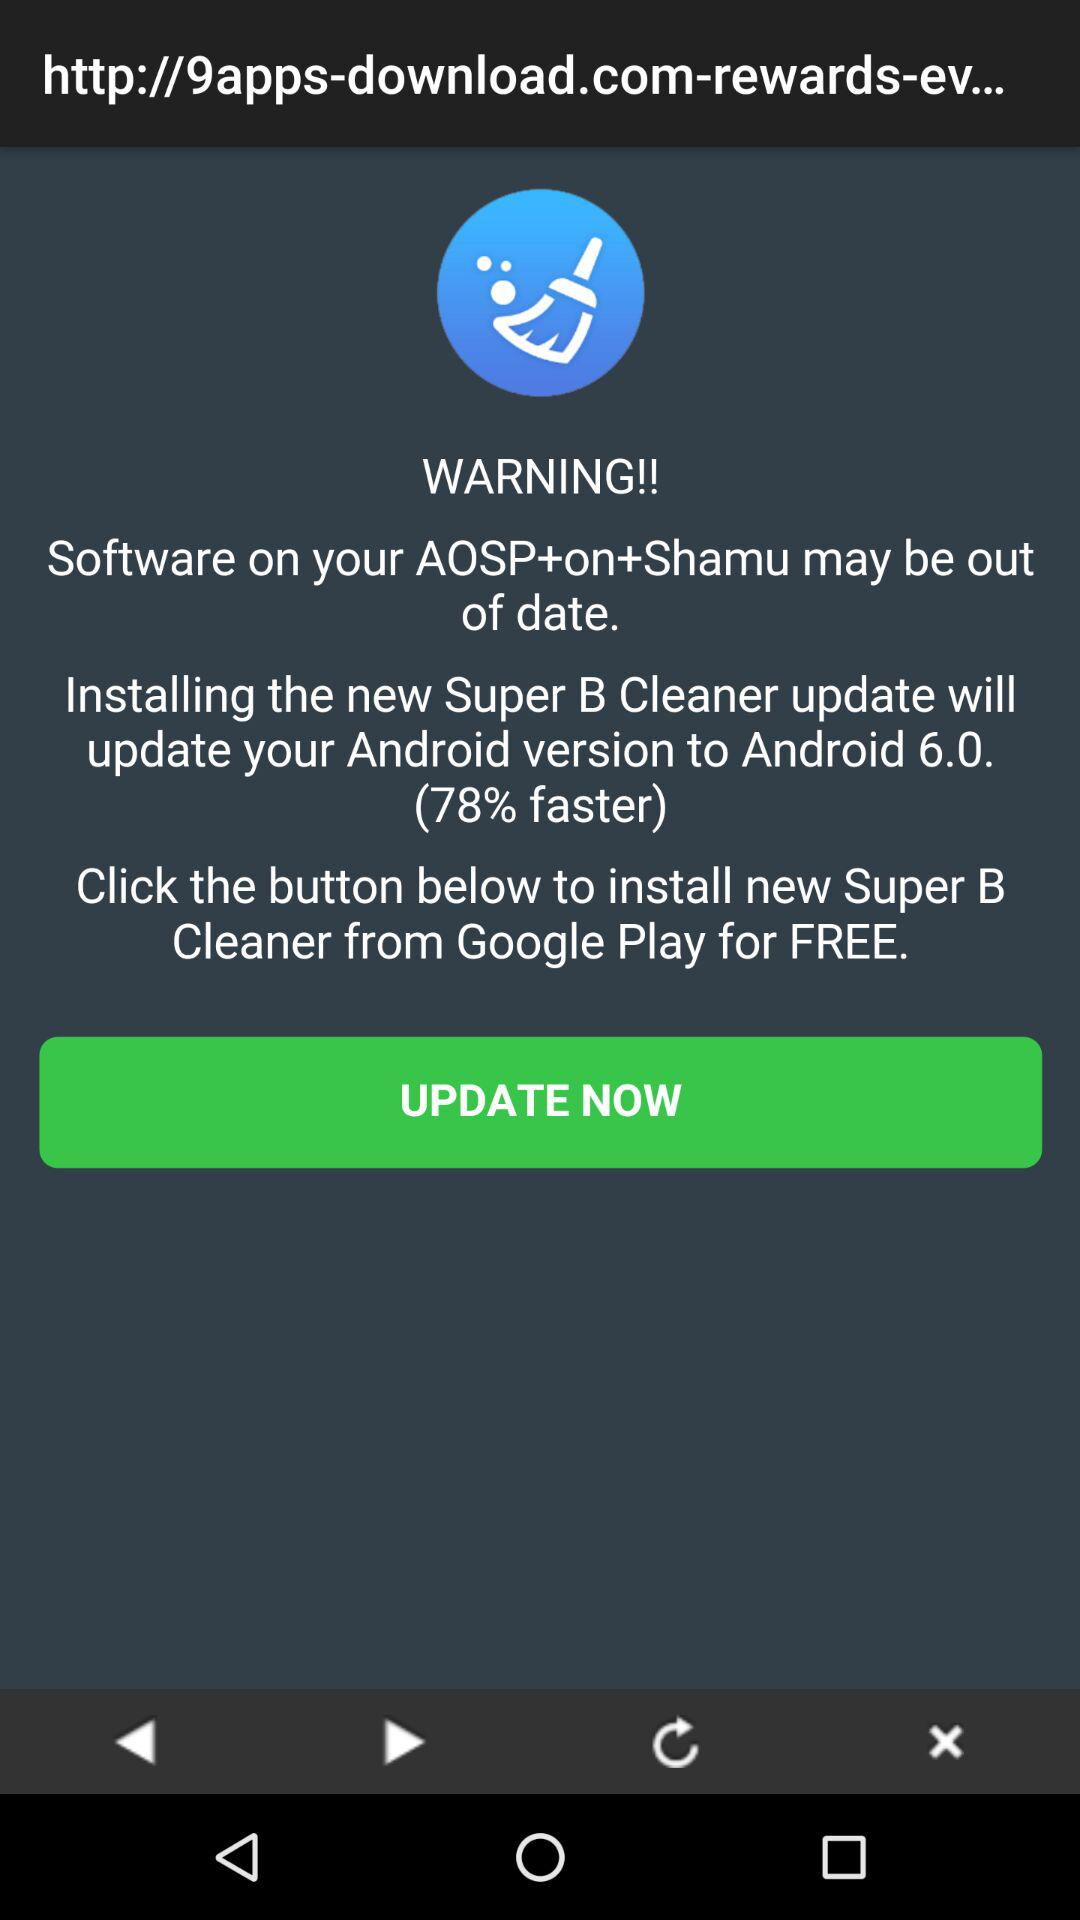Which update will update the Android version to Android 6.0? The new Super B Cleaner update will update the Android version to Android 6.0. 